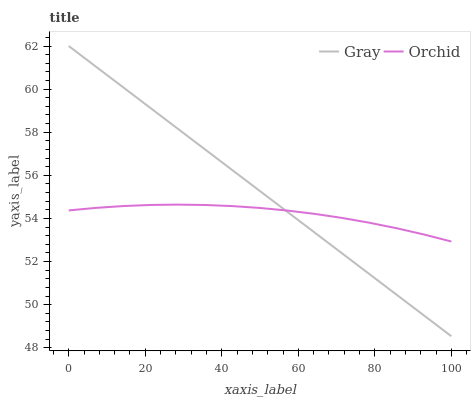Does Orchid have the minimum area under the curve?
Answer yes or no. Yes. Does Gray have the maximum area under the curve?
Answer yes or no. Yes. Does Orchid have the maximum area under the curve?
Answer yes or no. No. Is Gray the smoothest?
Answer yes or no. Yes. Is Orchid the roughest?
Answer yes or no. Yes. Is Orchid the smoothest?
Answer yes or no. No. Does Orchid have the lowest value?
Answer yes or no. No. Does Orchid have the highest value?
Answer yes or no. No. 